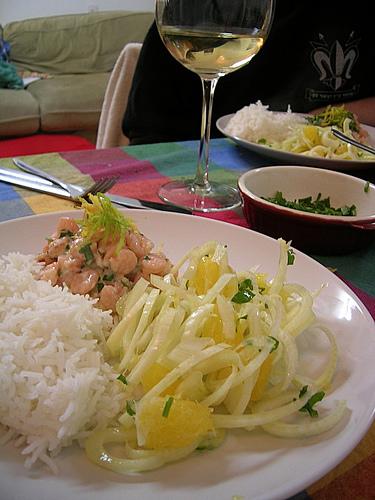How many plates are on the table?
Concise answer only. 2. What is the food on the left side?
Answer briefly. Rice. What is the food for?
Concise answer only. Eating. 